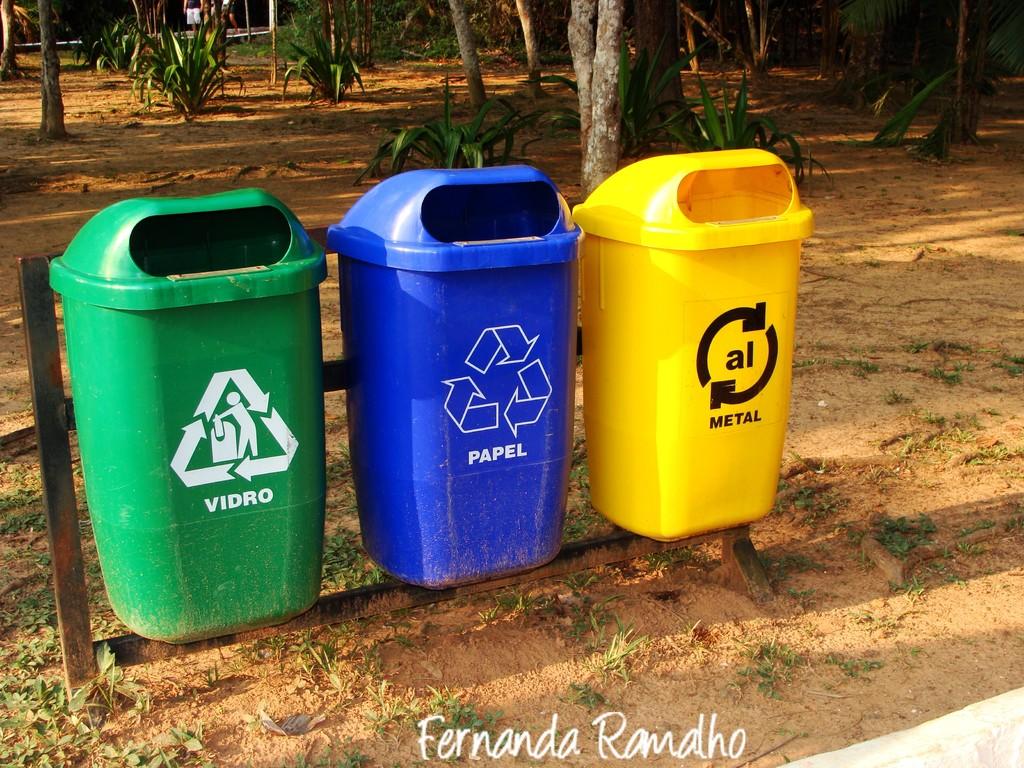What's under the symbol on the blue trash can?
Provide a short and direct response. Papel. What type of recycling goes in the yellow can?
Offer a terse response. Metal. 